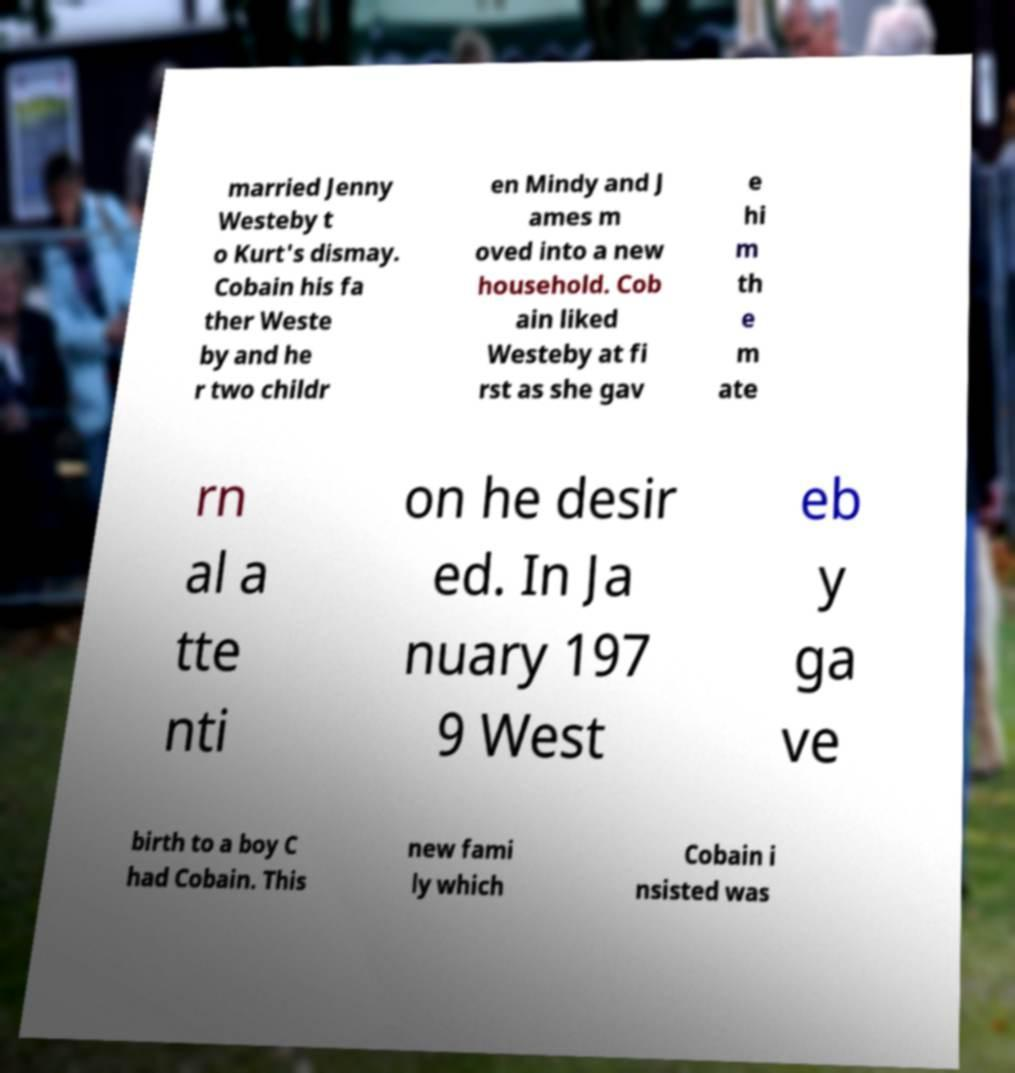What messages or text are displayed in this image? I need them in a readable, typed format. married Jenny Westeby t o Kurt's dismay. Cobain his fa ther Weste by and he r two childr en Mindy and J ames m oved into a new household. Cob ain liked Westeby at fi rst as she gav e hi m th e m ate rn al a tte nti on he desir ed. In Ja nuary 197 9 West eb y ga ve birth to a boy C had Cobain. This new fami ly which Cobain i nsisted was 